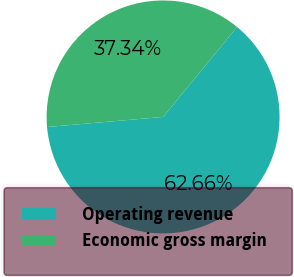Convert chart. <chart><loc_0><loc_0><loc_500><loc_500><pie_chart><fcel>Operating revenue<fcel>Economic gross margin<nl><fcel>62.66%<fcel>37.34%<nl></chart> 